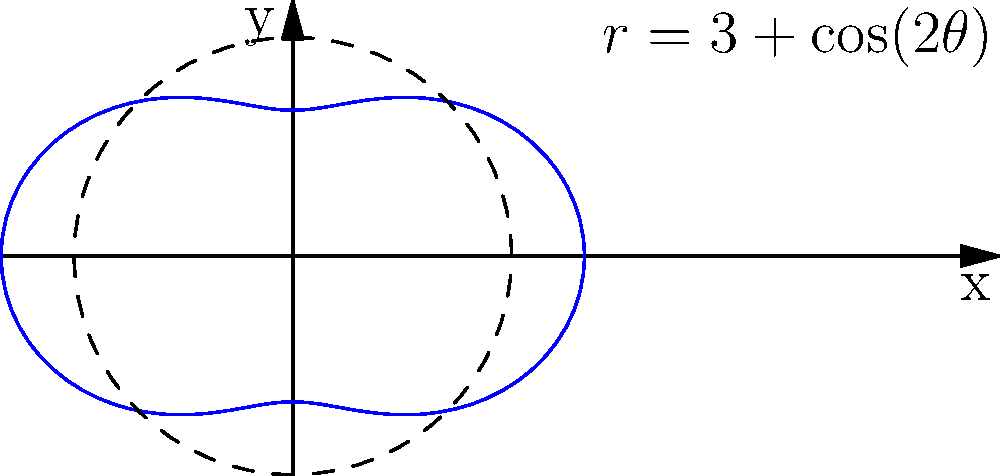As a horticulturist designing an irregularly shaped flower bed, you've modeled its boundary using the polar equation $r = 3 + \cos(2\theta)$. Calculate the area of this flower bed using polar integration. To find the area of the flower bed, we need to use the formula for area in polar coordinates:

$$A = \frac{1}{2} \int_0^{2\pi} r^2(\theta) d\theta$$

Where $r(\theta) = 3 + \cos(2\theta)$

Step 1: Square $r(\theta)$
$$r^2(\theta) = (3 + \cos(2\theta))^2 = 9 + 6\cos(2\theta) + \cos^2(2\theta)$$

Step 2: Set up the integral
$$A = \frac{1}{2} \int_0^{2\pi} (9 + 6\cos(2\theta) + \cos^2(2\theta)) d\theta$$

Step 3: Integrate each term
- $\int_0^{2\pi} 9 d\theta = 9\theta \bigg|_0^{2\pi} = 18\pi$
- $\int_0^{2\pi} 6\cos(2\theta) d\theta = 3\sin(2\theta) \bigg|_0^{2\pi} = 0$
- $\int_0^{2\pi} \cos^2(2\theta) d\theta = \frac{\theta}{2} + \frac{\sin(4\theta)}{8} \bigg|_0^{2\pi} = \pi$

Step 4: Sum the results and multiply by $\frac{1}{2}$
$$A = \frac{1}{2}(18\pi + 0 + \pi) = \frac{19\pi}{2}$$

Therefore, the area of the flower bed is $\frac{19\pi}{2}$ square units.
Answer: $\frac{19\pi}{2}$ square units 